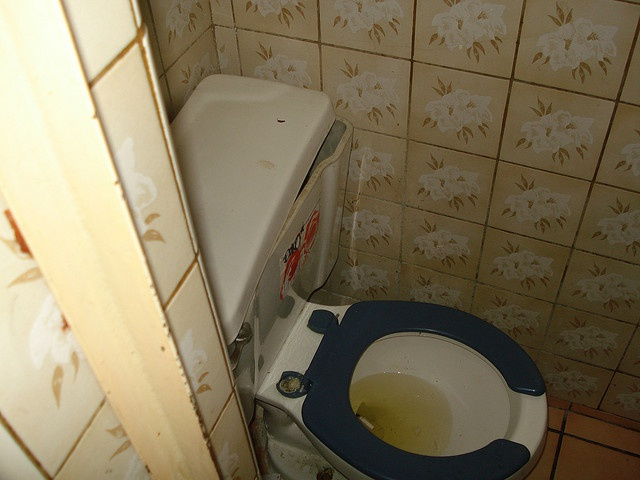Describe the objects in this image and their specific colors. I can see a toilet in lightyellow, black, gray, and olive tones in this image. 